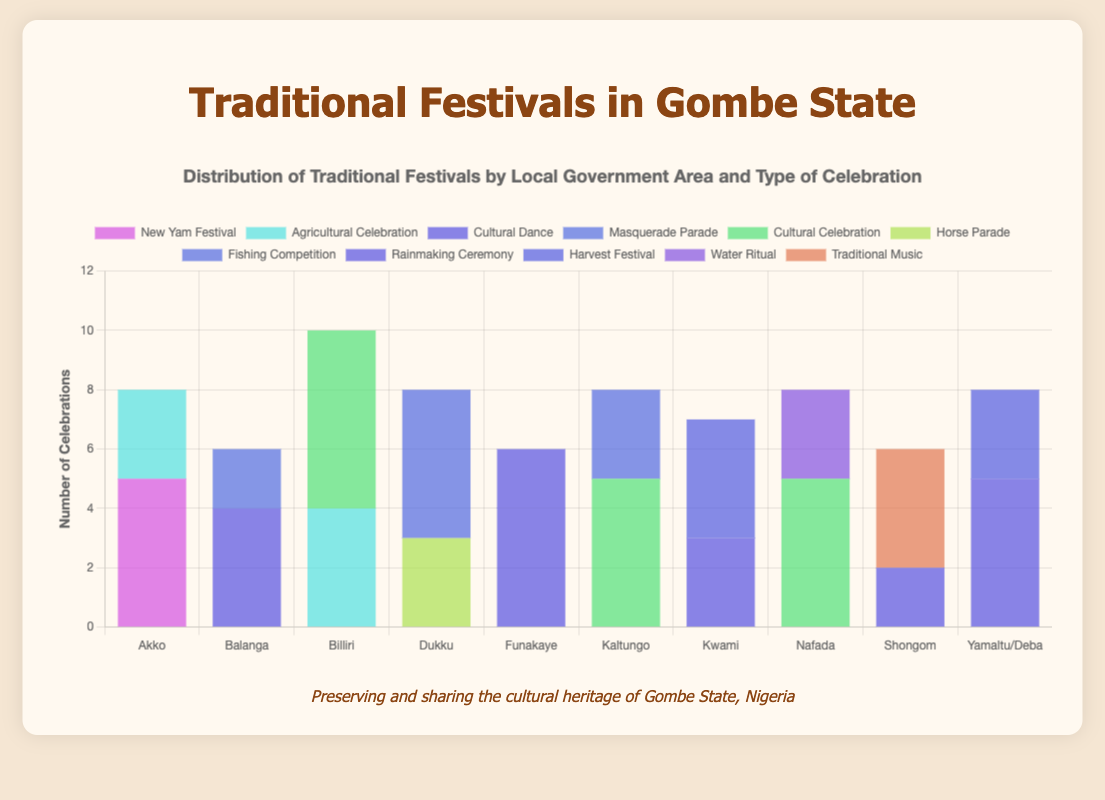What is the total number of celebrations in Akko? To find the total number of celebrations in Akko, sum up the "Number of Celebrations" for each festival in Akko. There are 5 celebrations for Posho Festival and 3 for Harvest Festival, so 5 + 3 = 8.
Answer: 8 Which Local Government Area has the highest number of Cultural Dance celebrations? Compare the "Number of Celebrations" for Cultural Dance in each Local Government Area. Balanga has 4, Funakaye has 4, Kwami has 3, and Yamaltu/Deba has 5. The highest number is 5 in Yamaltu/Deba.
Answer: Yamaltu/Deba What is the difference between the total celebrations in Billiri and Funakaye? Calculate the total for Billiri by summing the celebrations: Tangale Festival (6) + Harvest Festival (4) = 10. Do the same for Funakaye: Ritual Dance (4) + Rainmaker Festival (2) = 6. The difference is 10 - 6 = 4.
Answer: 4 What are the different types of celebrations represented in the figure? Identify the unique types of celebrations from the data provided. They are New Yam Festival, Agricultural Celebration, Cultural Dance, Masquerade Parade, Cultural Celebration, Horse Parade, Fishing Competition, Rainmaking Ceremony, Harvest Festival, Water Ritual, and Traditional Music.
Answer: New Yam Festival, Agricultural Celebration, Cultural Dance, Masquerade Parade, Cultural Celebration, Horse Parade, Fishing Competition, Rainmaking Ceremony, Harvest Festival, Water Ritual, Traditional Music Which Local Government Area has the highest total number of celebrations across all types? Sum the "Number of Celebrations" for each Local Government Area: Akko (5+3=8), Balanga (4+2=6), Billiri (6+4=10), Dukku (3+5=8), Funakaye (4+2=6), Kaltungo (3+5=8), Kwami (3+4=7), Nafada (5+3=8), Shongom (4+2=6), Yamaltu/Deba (3+5=8). Billiri has the highest total of 10 celebrations.
Answer: Billiri Which type of celebration is most common in the entire chart? Identify each type of celebration and sum the "Number of Celebrations" across all Local Government Areas. Cultural Dance appears in Balanga (4), Funakaye (4), Kwami (3), and Yamaltu/Deba (5), making it the most common with 16 celebrations in total.
Answer: Cultural Dance 